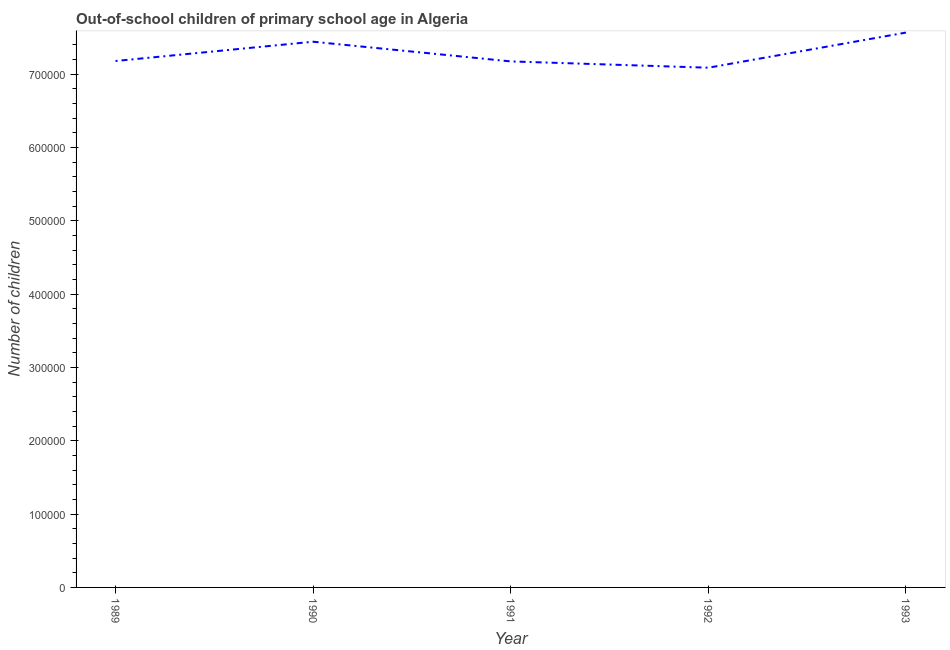What is the number of out-of-school children in 1989?
Provide a short and direct response. 7.18e+05. Across all years, what is the maximum number of out-of-school children?
Ensure brevity in your answer.  7.57e+05. Across all years, what is the minimum number of out-of-school children?
Keep it short and to the point. 7.09e+05. In which year was the number of out-of-school children maximum?
Provide a short and direct response. 1993. In which year was the number of out-of-school children minimum?
Make the answer very short. 1992. What is the sum of the number of out-of-school children?
Your answer should be very brief. 3.65e+06. What is the difference between the number of out-of-school children in 1990 and 1992?
Provide a succinct answer. 3.54e+04. What is the average number of out-of-school children per year?
Keep it short and to the point. 7.29e+05. What is the median number of out-of-school children?
Your answer should be very brief. 7.18e+05. In how many years, is the number of out-of-school children greater than 620000 ?
Your answer should be compact. 5. What is the ratio of the number of out-of-school children in 1989 to that in 1990?
Your answer should be very brief. 0.96. Is the number of out-of-school children in 1991 less than that in 1993?
Give a very brief answer. Yes. What is the difference between the highest and the second highest number of out-of-school children?
Offer a very short reply. 1.25e+04. What is the difference between the highest and the lowest number of out-of-school children?
Offer a very short reply. 4.79e+04. In how many years, is the number of out-of-school children greater than the average number of out-of-school children taken over all years?
Your answer should be very brief. 2. Does the number of out-of-school children monotonically increase over the years?
Your answer should be compact. No. How many years are there in the graph?
Offer a terse response. 5. What is the difference between two consecutive major ticks on the Y-axis?
Your answer should be compact. 1.00e+05. Are the values on the major ticks of Y-axis written in scientific E-notation?
Provide a succinct answer. No. Does the graph contain any zero values?
Make the answer very short. No. What is the title of the graph?
Your answer should be very brief. Out-of-school children of primary school age in Algeria. What is the label or title of the Y-axis?
Offer a terse response. Number of children. What is the Number of children of 1989?
Offer a very short reply. 7.18e+05. What is the Number of children of 1990?
Give a very brief answer. 7.44e+05. What is the Number of children of 1991?
Provide a short and direct response. 7.17e+05. What is the Number of children of 1992?
Ensure brevity in your answer.  7.09e+05. What is the Number of children of 1993?
Provide a short and direct response. 7.57e+05. What is the difference between the Number of children in 1989 and 1990?
Your answer should be very brief. -2.63e+04. What is the difference between the Number of children in 1989 and 1991?
Make the answer very short. 544. What is the difference between the Number of children in 1989 and 1992?
Offer a terse response. 9137. What is the difference between the Number of children in 1989 and 1993?
Your answer should be very brief. -3.88e+04. What is the difference between the Number of children in 1990 and 1991?
Your answer should be very brief. 2.69e+04. What is the difference between the Number of children in 1990 and 1992?
Your response must be concise. 3.54e+04. What is the difference between the Number of children in 1990 and 1993?
Provide a succinct answer. -1.25e+04. What is the difference between the Number of children in 1991 and 1992?
Give a very brief answer. 8593. What is the difference between the Number of children in 1991 and 1993?
Offer a very short reply. -3.93e+04. What is the difference between the Number of children in 1992 and 1993?
Offer a terse response. -4.79e+04. What is the ratio of the Number of children in 1989 to that in 1990?
Offer a very short reply. 0.96. What is the ratio of the Number of children in 1989 to that in 1991?
Ensure brevity in your answer.  1. What is the ratio of the Number of children in 1989 to that in 1993?
Ensure brevity in your answer.  0.95. What is the ratio of the Number of children in 1990 to that in 1992?
Offer a terse response. 1.05. What is the ratio of the Number of children in 1991 to that in 1992?
Keep it short and to the point. 1.01. What is the ratio of the Number of children in 1991 to that in 1993?
Make the answer very short. 0.95. What is the ratio of the Number of children in 1992 to that in 1993?
Make the answer very short. 0.94. 